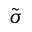<formula> <loc_0><loc_0><loc_500><loc_500>\tilde { \sigma }</formula> 